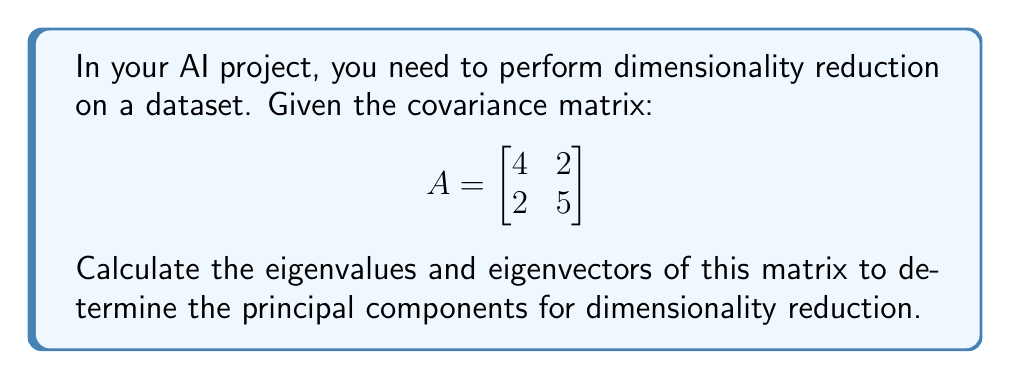Teach me how to tackle this problem. To find the eigenvalues and eigenvectors of matrix A:

1. Calculate the characteristic equation:
   $\det(A - \lambda I) = 0$
   
   $$\begin{vmatrix}
   4-\lambda & 2 \\
   2 & 5-\lambda
   \end{vmatrix} = 0$$

2. Expand the determinant:
   $(4-\lambda)(5-\lambda) - 4 = 0$
   $\lambda^2 - 9\lambda + 16 = 0$

3. Solve the quadratic equation:
   $\lambda = \frac{9 \pm \sqrt{81 - 64}}{2} = \frac{9 \pm \sqrt{17}}{2}$

   Eigenvalues: $\lambda_1 = \frac{9 + \sqrt{17}}{2}$, $\lambda_2 = \frac{9 - \sqrt{17}}{2}$

4. Find eigenvectors for each eigenvalue:
   For $\lambda_1$:
   $$(A - \lambda_1 I)\vec{v_1} = \vec{0}$$
   $$\begin{bmatrix}
   4-\frac{9+\sqrt{17}}{2} & 2 \\
   2 & 5-\frac{9+\sqrt{17}}{2}
   \end{bmatrix}\begin{bmatrix}
   x \\
   y
   \end{bmatrix} = \begin{bmatrix}
   0 \\
   0
   \end{bmatrix}$$

   Solving this system, we get: $\vec{v_1} = \begin{bmatrix}
   1 \\
   \frac{\sqrt{17}-1}{4}
   \end{bmatrix}$

   For $\lambda_2$:
   $$(A - \lambda_2 I)\vec{v_2} = \vec{0}$$
   $$\begin{bmatrix}
   4-\frac{9-\sqrt{17}}{2} & 2 \\
   2 & 5-\frac{9-\sqrt{17}}{2}
   \end{bmatrix}\begin{bmatrix}
   x \\
   y
   \end{bmatrix} = \begin{bmatrix}
   0 \\
   0
   \end{bmatrix}$$

   Solving this system, we get: $\vec{v_2} = \begin{bmatrix}
   1 \\
   -\frac{\sqrt{17}+1}{4}
   \end{bmatrix}$

5. Normalize the eigenvectors:
   $\vec{v_1} = \frac{1}{\sqrt{1 + (\frac{\sqrt{17}-1}{4})^2}}\begin{bmatrix}
   1 \\
   \frac{\sqrt{17}-1}{4}
   \end{bmatrix}$

   $\vec{v_2} = \frac{1}{\sqrt{1 + (-\frac{\sqrt{17}+1}{4})^2}}\begin{bmatrix}
   1 \\
   -\frac{\sqrt{17}+1}{4}
   \end{bmatrix}$
Answer: Eigenvalues: $\lambda_1 = \frac{9 + \sqrt{17}}{2}$, $\lambda_2 = \frac{9 - \sqrt{17}}{2}$

Normalized eigenvectors:
$\vec{v_1} = \frac{1}{\sqrt{1 + (\frac{\sqrt{17}-1}{4})^2}}\begin{bmatrix}
1 \\
\frac{\sqrt{17}-1}{4}
\end{bmatrix}$, $\vec{v_2} = \frac{1}{\sqrt{1 + (-\frac{\sqrt{17}+1}{4})^2}}\begin{bmatrix}
1 \\
-\frac{\sqrt{17}+1}{4}
\end{bmatrix}$ 